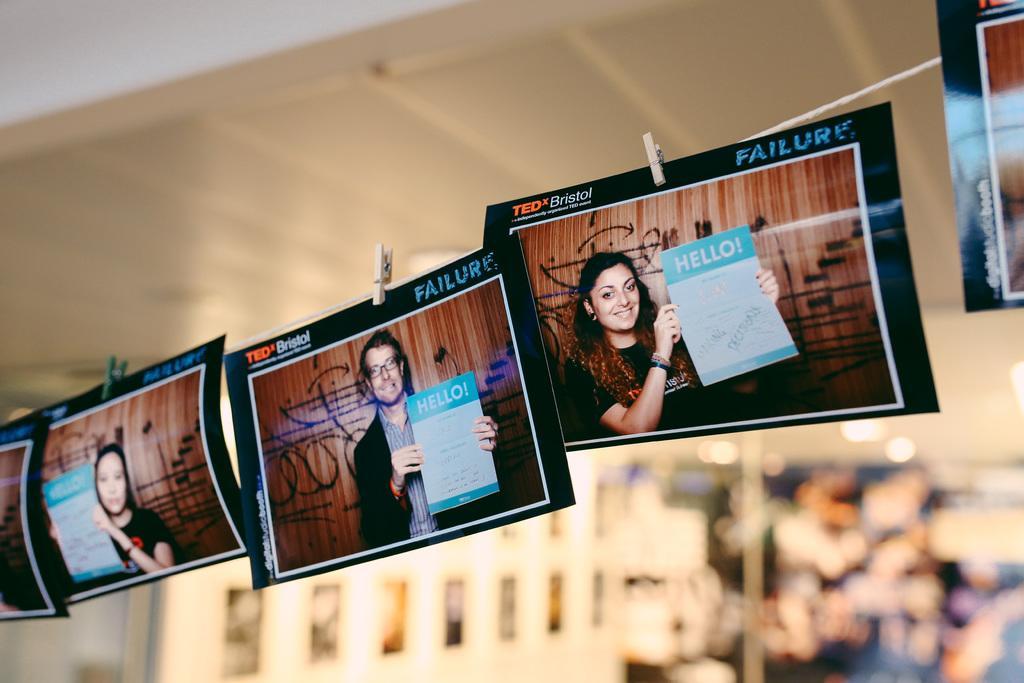In one or two sentences, can you explain what this image depicts? In the picture we can see a thread on it, we can see some photographs, are clipped and on the photographs we can see some person images and they are holding a paper and written on it as HELLO and behind it we can see some things which are not clearly visible. 